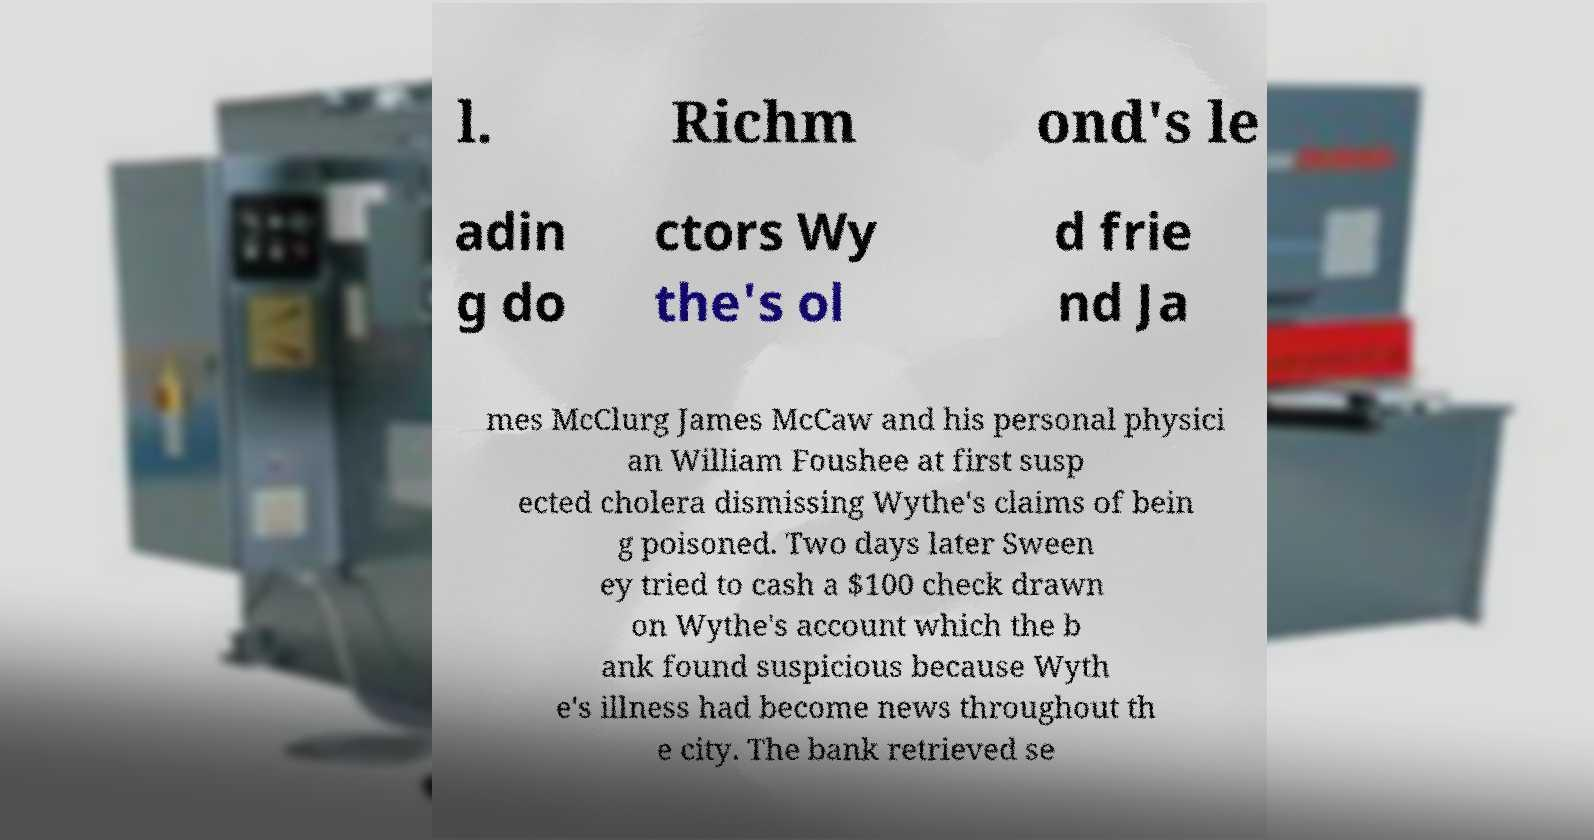Could you extract and type out the text from this image? l. Richm ond's le adin g do ctors Wy the's ol d frie nd Ja mes McClurg James McCaw and his personal physici an William Foushee at first susp ected cholera dismissing Wythe's claims of bein g poisoned. Two days later Sween ey tried to cash a $100 check drawn on Wythe's account which the b ank found suspicious because Wyth e's illness had become news throughout th e city. The bank retrieved se 